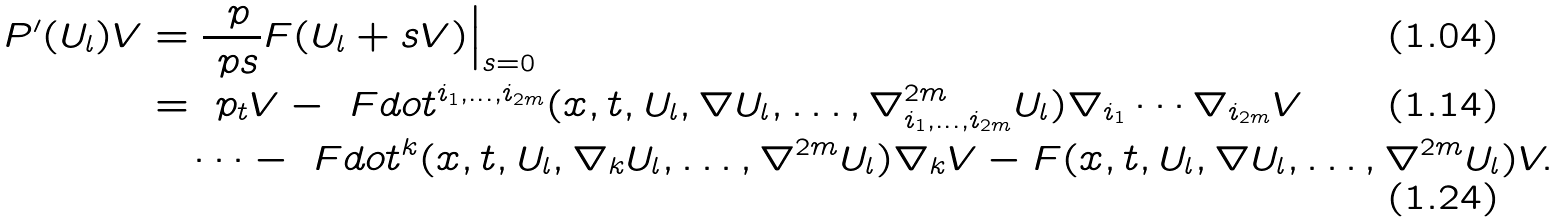Convert formula to latex. <formula><loc_0><loc_0><loc_500><loc_500>P ^ { \prime } ( U _ { l } ) V & = \frac { \ p } { \ p s } F ( U _ { l } + s V ) \Big | _ { s = 0 } \\ & = \ p _ { t } V - \ F d o t ^ { i _ { 1 } , \dots , i _ { 2 m } } ( x , t , U _ { l } , \nabla U _ { l } , \dots , \nabla ^ { 2 m } _ { i _ { 1 } , \dots , i _ { 2 m } } U _ { l } ) \nabla _ { i _ { 1 } } \cdots \nabla _ { i _ { 2 m } } V \\ & \quad \cdots - \ F d o t ^ { k } ( x , t , U _ { l } , \nabla _ { k } U _ { l } , \dots , \nabla ^ { 2 m } U _ { l } ) \nabla _ { k } V - F ( x , t , U _ { l } , \nabla U _ { l } , \dots , \nabla ^ { 2 m } U _ { l } ) V .</formula> 